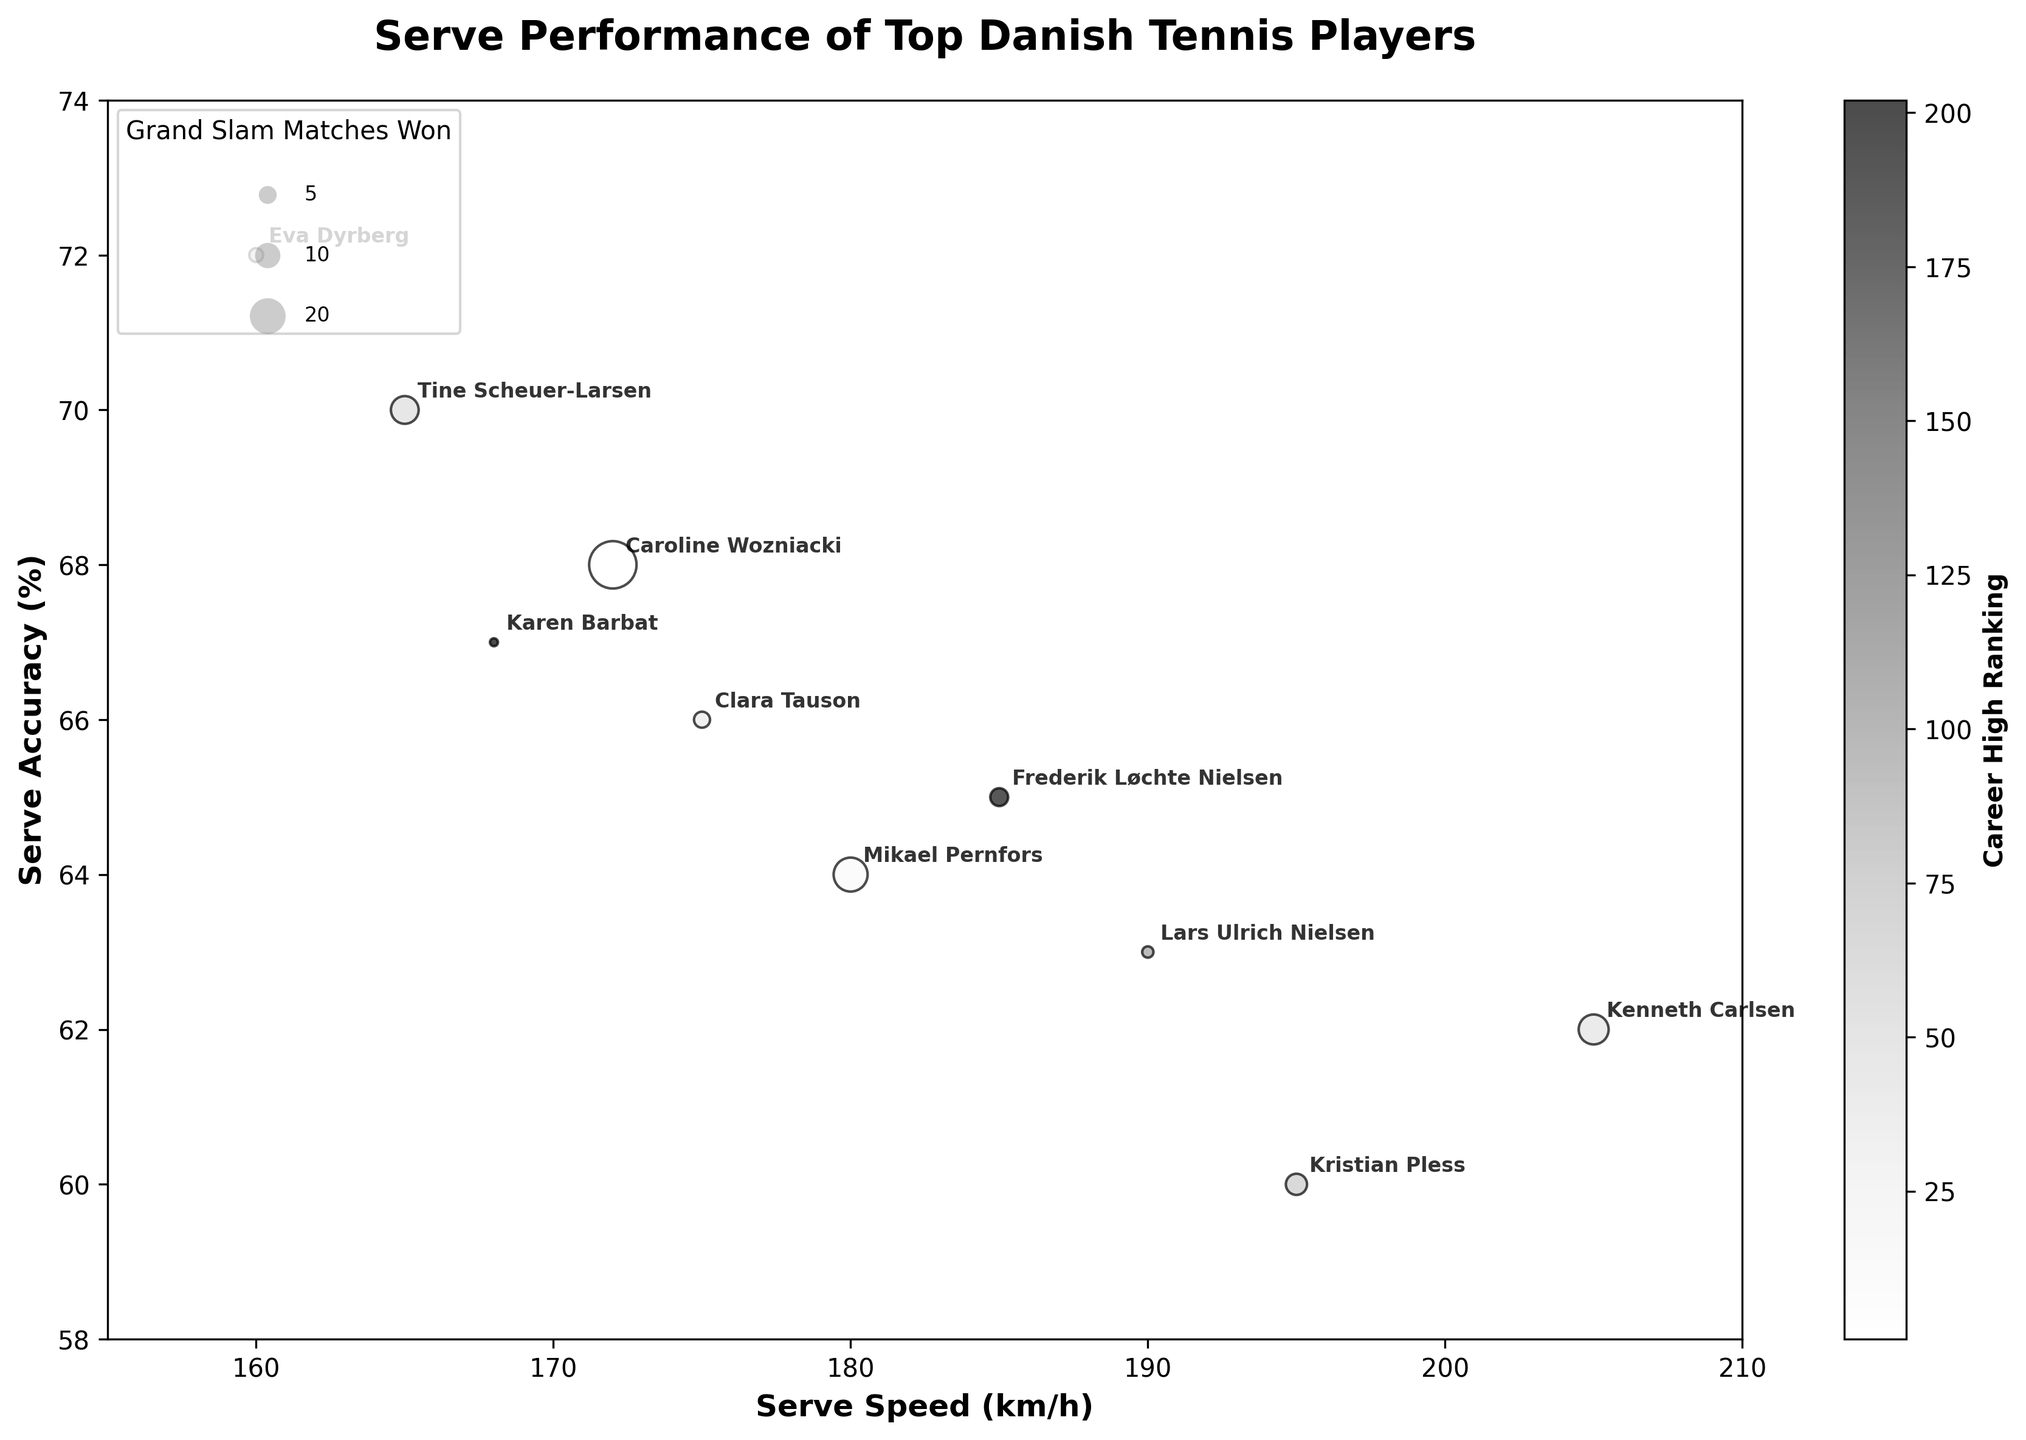What's the title of the figure? The title is usually found at the top of the figure. It is provided to give a summary of what the figure represents. In this case, it should help understand the context of the data points.
Answer: Serve Performance of Top Danish Tennis Players How is the serve accuracy between Tine Scheuer-Larsen and Clara Tauson different? Tine Scheuer-Larsen has a serve accuracy of 70%, while Clara Tauson has 66%. By comparing these percentages, we see that Tine Scheuer-Larsen has a higher serve accuracy by 4 percentage points.
Answer: Tine Scheuer-Larsen's accuracy is 4% higher Which player has the fastest serve speed and what is that speed? The fastest serve speed can be identified by looking for the highest value on the x-axis in the scatter plot. The player associated with that data point is Kenneth Carlsen, with a serve speed of 205 km/h.
Answer: Kenneth Carlsen with 205 km/h Who has the highest career high ranking among the players, and what is the ranking? The color bar is used to depict the career high ranking, where deeper colors signify better rankings. Caroline Wozniacki has the highest career high ranking of 1.
Answer: Caroline Wozniacki with ranking 1 How many players have won more than 10 Grand Slam matches? The size of the points in the scatter plot represents the number of Grand Slam matches won. By examining the larger bubbles, we can count the players who have won more than 10 matches. There are 3 such players: Caroline Wozniacki, Mikael Pernfors, and Kenneth Carlsen.
Answer: 3 players What's the average serve accuracy of the top three players by career high ranking? To determine this, identify the top three players by career high ranking, which are Caroline Wozniacki, Mikael Pernfors, and Clara Tauson. Their serve accuracies are 68%, 64%, and 66%, respectively. The average is calculated as (68 + 64 + 66) / 3 = 66%.
Answer: 66% Which player has the best combination of serve speed and accuracy? The best combination would likely be a player with relatively high values in both metrics. Kenneth Carlsen has a serve speed of 205 km/h and an accuracy of 62%, making him a strong contender. Caroline Wozniacki is another candidate with decent values in both metrics but slightly lower in serve speed. Kenneth Carlsen stands out more significantly.
Answer: Kenneth Carlsen What range of values is represented on the serve speed axis? The axis limits for serve speed can be observed from the minimum and maximum values on the x-axis. It ranges from 155 km/h to 210 km/h.
Answer: 155 km/h to 210 km/h How does Caroline Wozniacki's serve accuracy compare with Eva Dyrberg's? Caroline Wozniacki's serve accuracy is 68%, while Eva Dyrberg's is 72%. Hence, Eva Dyrberg's serve accuracy is 4% higher than Caroline Wozniacki's.
Answer: Eva Dyrberg is 4% higher 